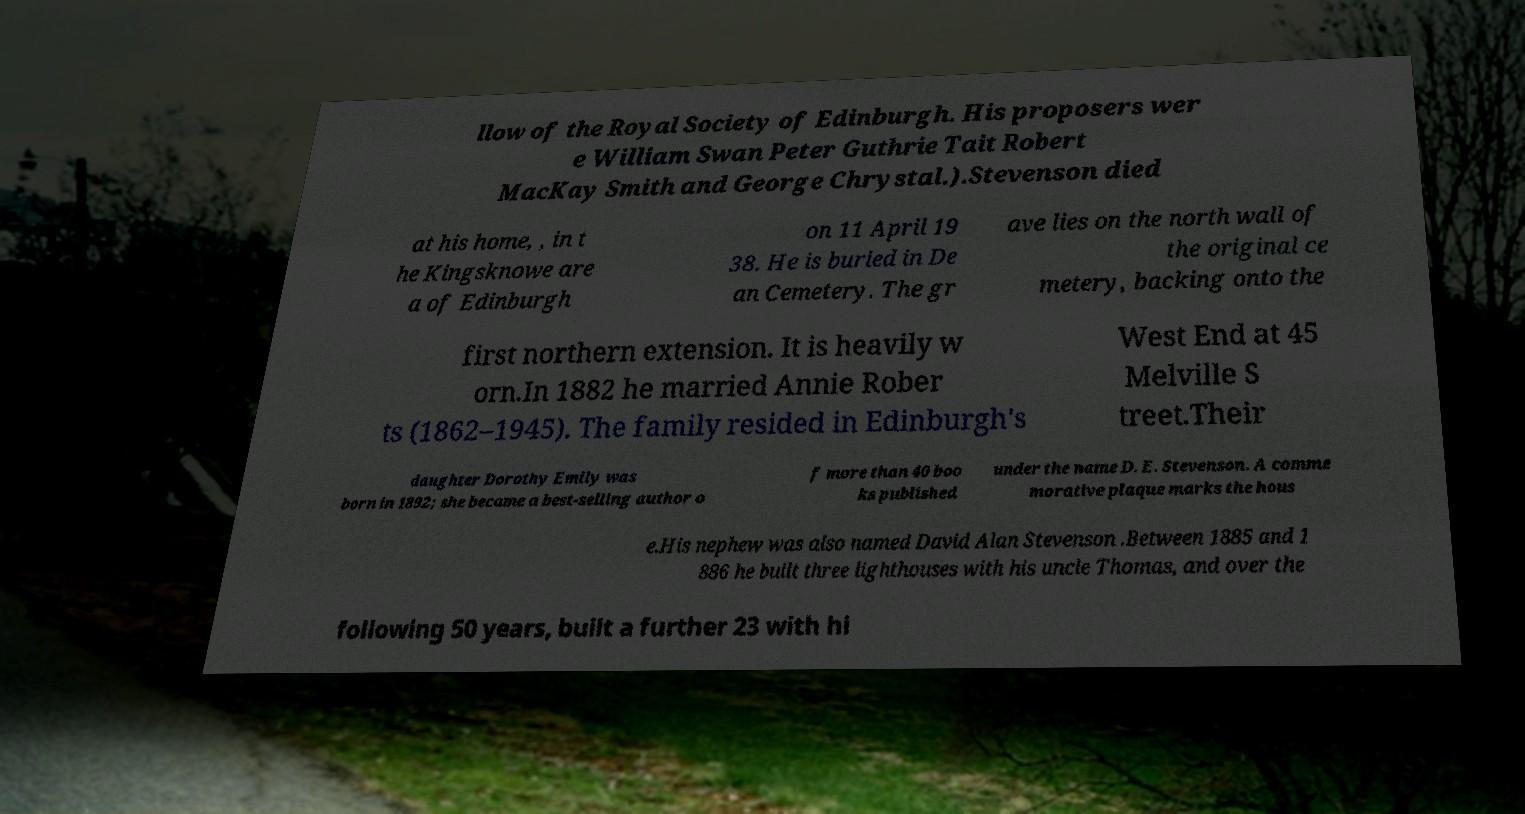Can you read and provide the text displayed in the image?This photo seems to have some interesting text. Can you extract and type it out for me? llow of the Royal Society of Edinburgh. His proposers wer e William Swan Peter Guthrie Tait Robert MacKay Smith and George Chrystal.).Stevenson died at his home, , in t he Kingsknowe are a of Edinburgh on 11 April 19 38. He is buried in De an Cemetery. The gr ave lies on the north wall of the original ce metery, backing onto the first northern extension. It is heavily w orn.In 1882 he married Annie Rober ts (1862–1945). The family resided in Edinburgh's West End at 45 Melville S treet.Their daughter Dorothy Emily was born in 1892; she became a best-selling author o f more than 40 boo ks published under the name D. E. Stevenson. A comme morative plaque marks the hous e.His nephew was also named David Alan Stevenson .Between 1885 and 1 886 he built three lighthouses with his uncle Thomas, and over the following 50 years, built a further 23 with hi 